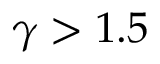<formula> <loc_0><loc_0><loc_500><loc_500>\gamma > 1 . 5</formula> 